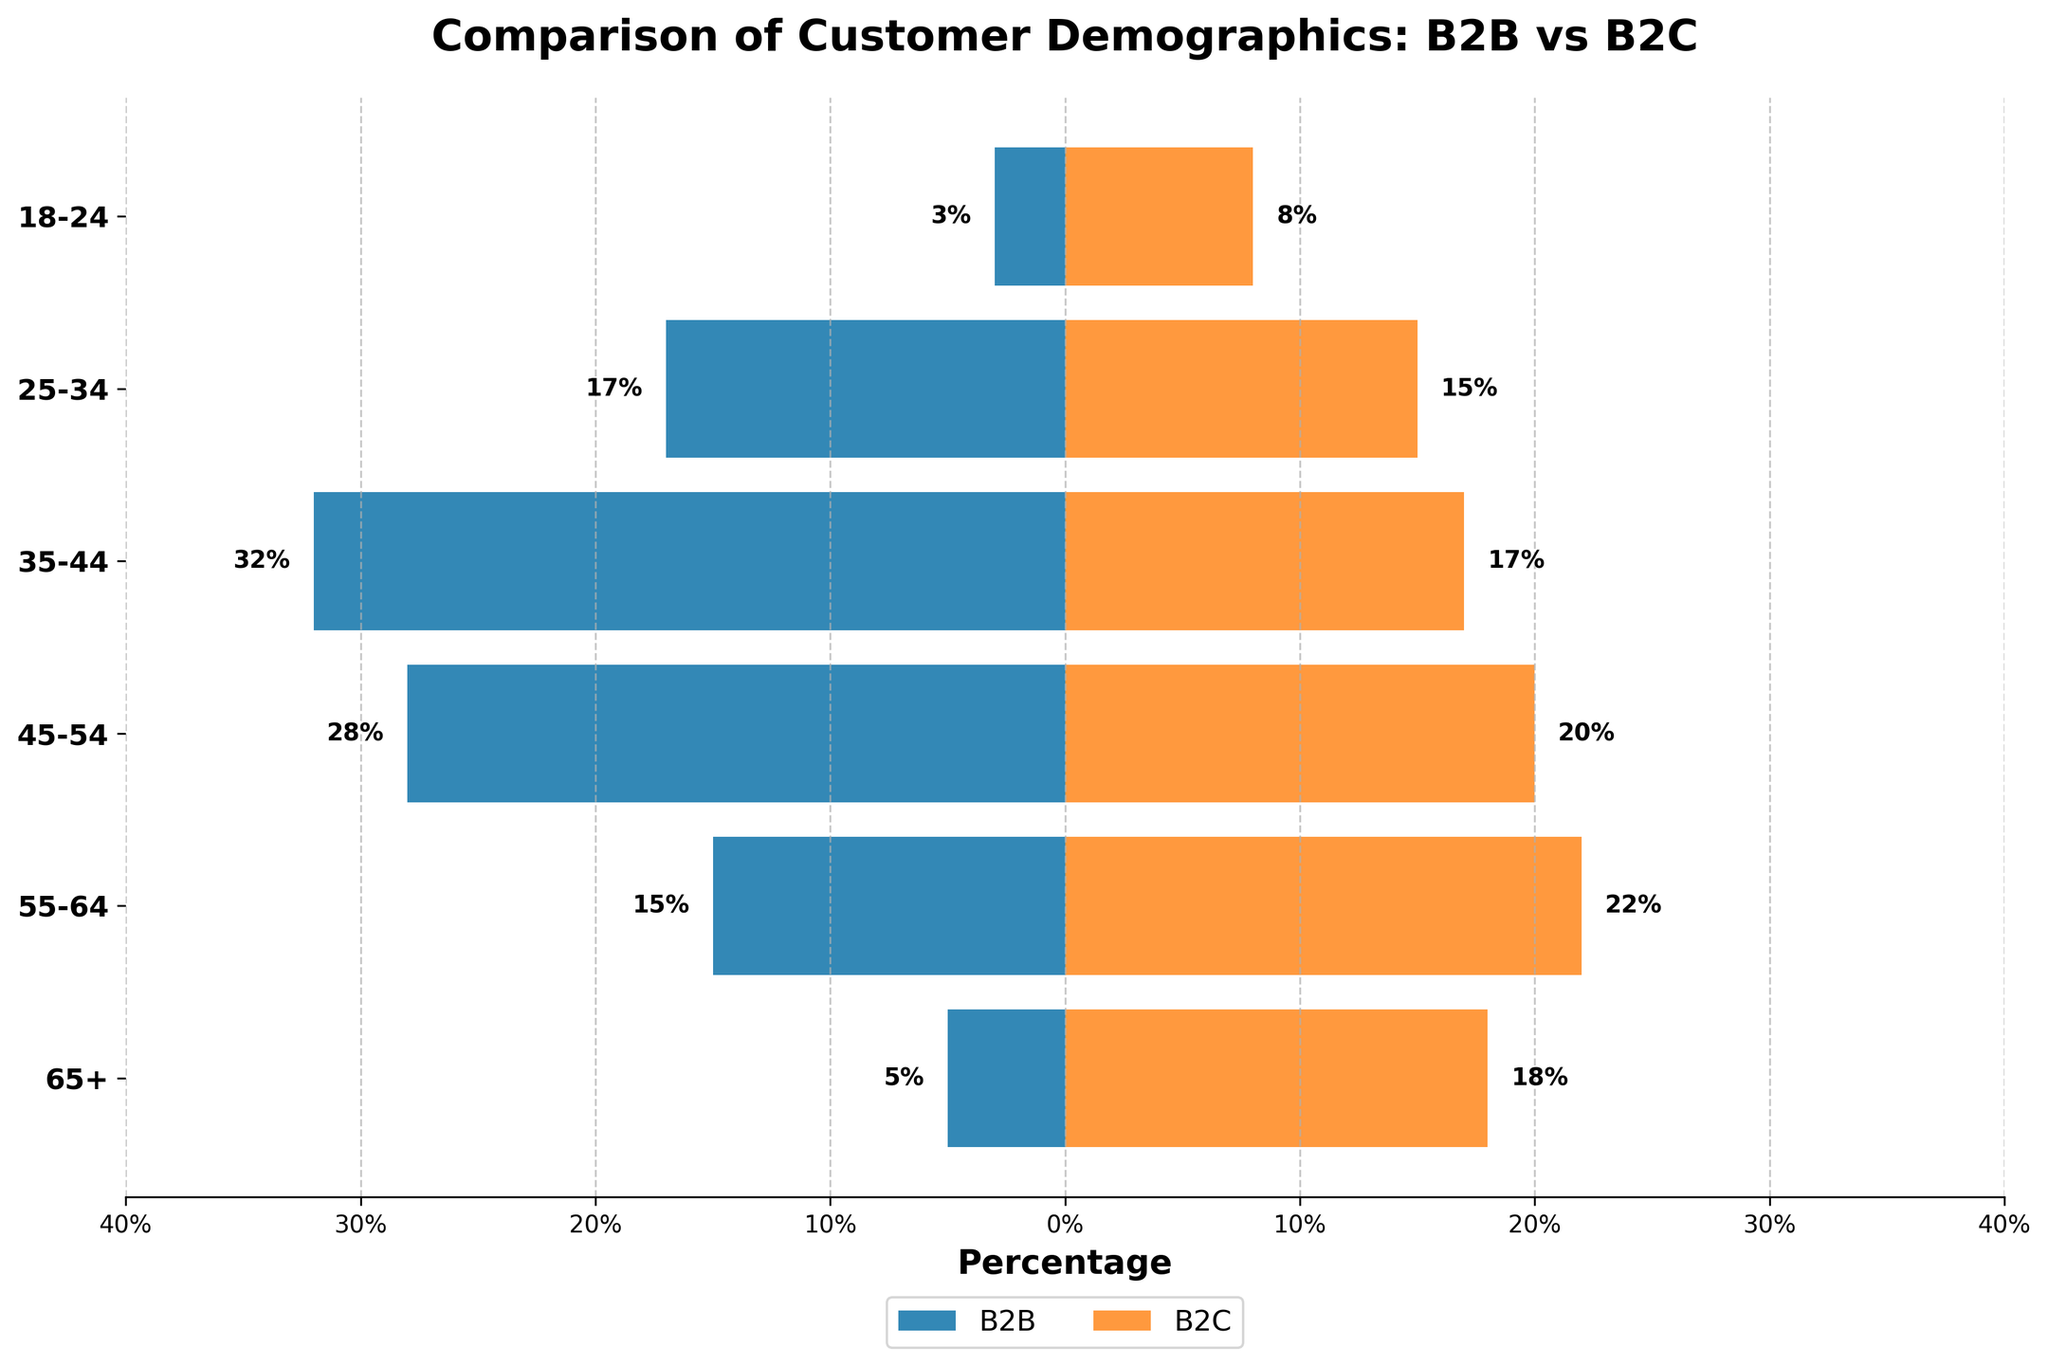What is the title of the figure? The title is located at the top center of the figure and is written in bold text.
Answer: Comparison of Customer Demographics: B2B vs B2C How many age groups are represented in the figure? The y-axis displays the age groups, and counting them will give the total number.
Answer: 6 Which age group shows the highest percentage for B2C customers? Look at the B2C bars (colored in orange) and identify the one with the highest value.
Answer: 55-64 What is the difference in percentage between B2B and B2C customers in the 35-44 age group? Find the values for B2B and B2C in the 35-44 age group, then subtract the smaller number from the larger one.
Answer: 15 In which age group is the percentage of B2B customers closest to the percentage of B2C customers? Compare the values of B2B and B2C customers for each age group and find the one with the smallest difference.
Answer: 25-34 What is the sum of the percentages of B2C customers in the 18-24 and 65+ age groups? Add the percentages given for B2C customers in the 18-24 and 65+ age groups.
Answer: 26 How many age groups have a higher percentage of B2B customers compared to B2C customers? Compare the percentages of B2B and B2C customers for each age group and count how many times the B2B value is higher.
Answer: 3 What percentage of B2B customers are in the 45-54 age group? Locate the 45-54 age group on the y-axis and find the corresponding B2B bar (colored in blue).
Answer: 28% Which age group shows the largest gap between B2B and B2C customers? Examine all age groups and identify the one with the largest absolute difference between B2B and B2C percentages.
Answer: 65+ What is the average percentage of B2C customers across all age groups? Add all the B2C percentage values and divide by the number of age groups (6). (18 + 22 + 20 + 17 + 15 + 8) = 100, so 100/6 ≈ 16.67
Answer: 16.67 